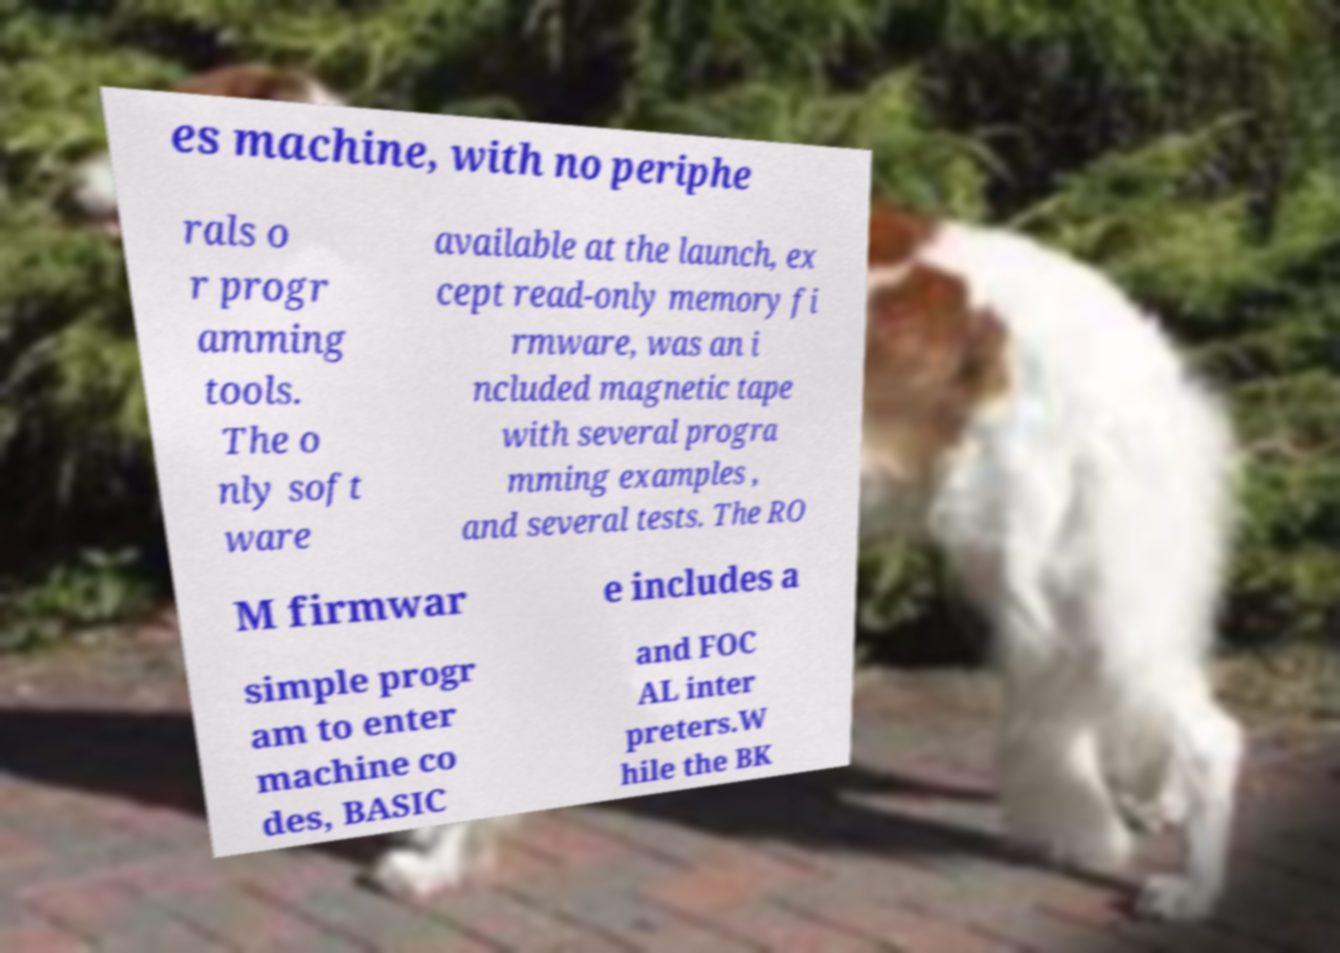Could you extract and type out the text from this image? es machine, with no periphe rals o r progr amming tools. The o nly soft ware available at the launch, ex cept read-only memory fi rmware, was an i ncluded magnetic tape with several progra mming examples , and several tests. The RO M firmwar e includes a simple progr am to enter machine co des, BASIC and FOC AL inter preters.W hile the BK 